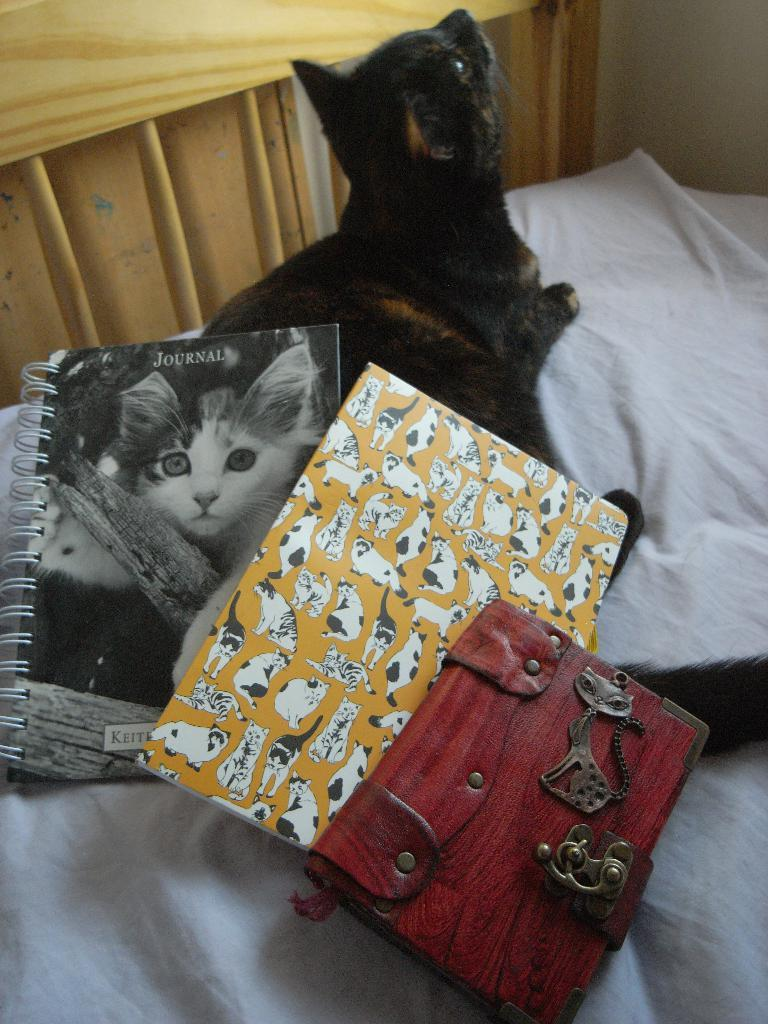What type of animal is in the image? There is a black color cat in the image. What objects can be seen related to learning or reading? There are books in the image. What personal item is visible in the image? There is a wallet in the image. What color is the cloth in the image? The cloth in the image is white color. What architectural feature is present in the image? There is a window in the image. What type of flowers can be seen growing near the cat in the image? There are no flowers visible in the image; it only features a cat, books, a wallet, a white color cloth, and a window. 